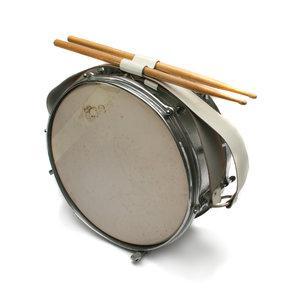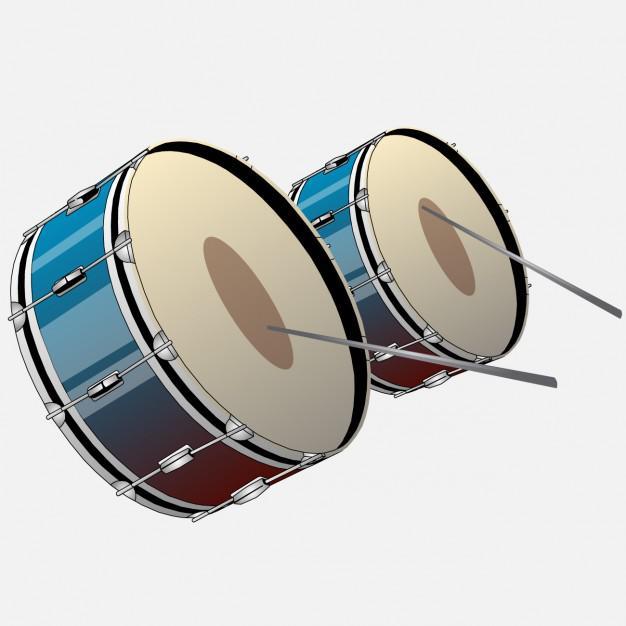The first image is the image on the left, the second image is the image on the right. Analyze the images presented: Is the assertion "There are four drum sticks." valid? Answer yes or no. Yes. 